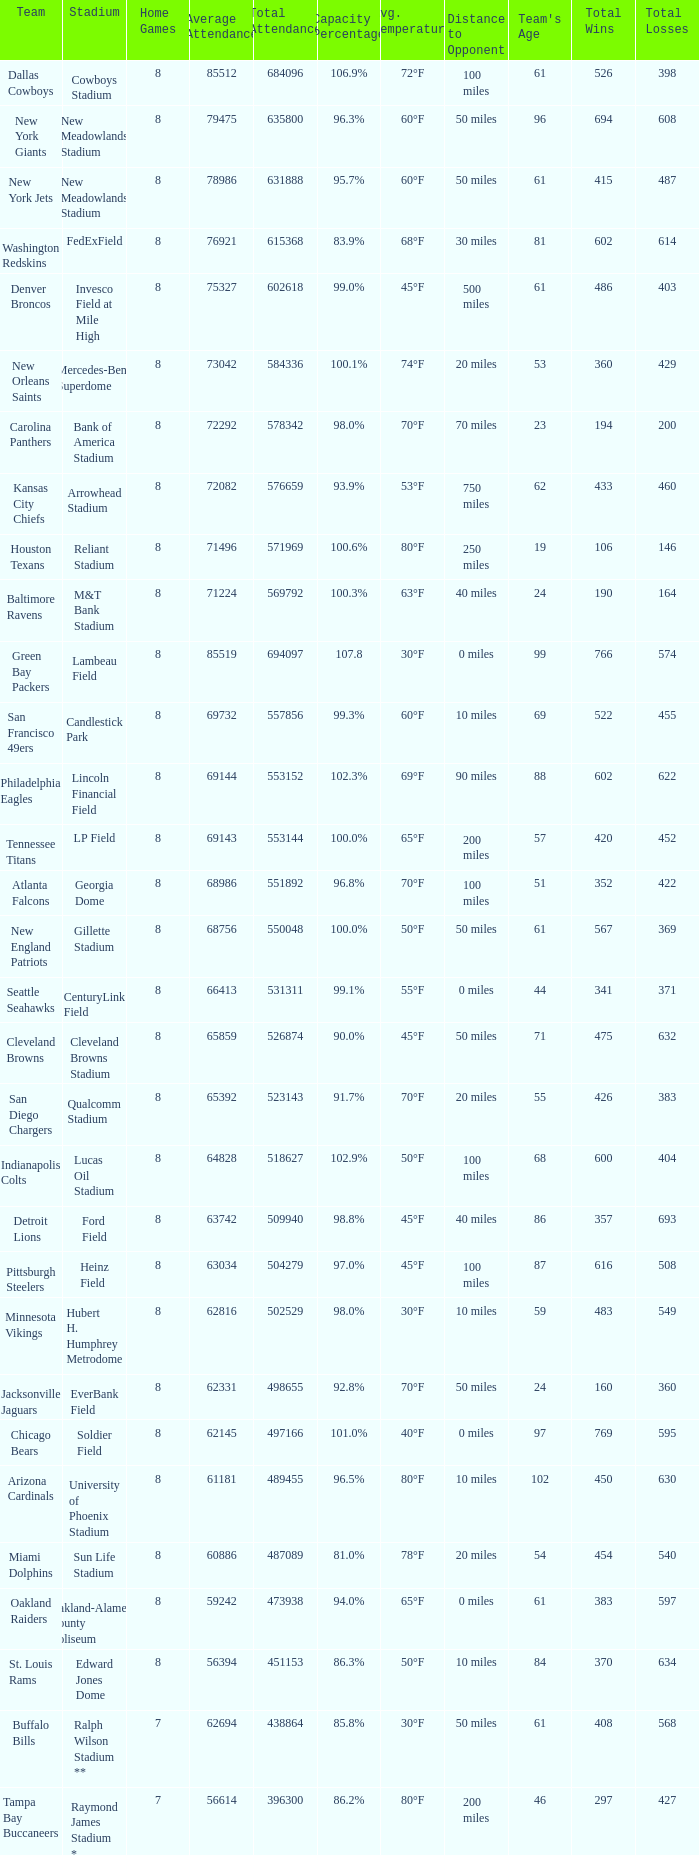How many average attendance has a capacity percentage of 96.5% 1.0. 